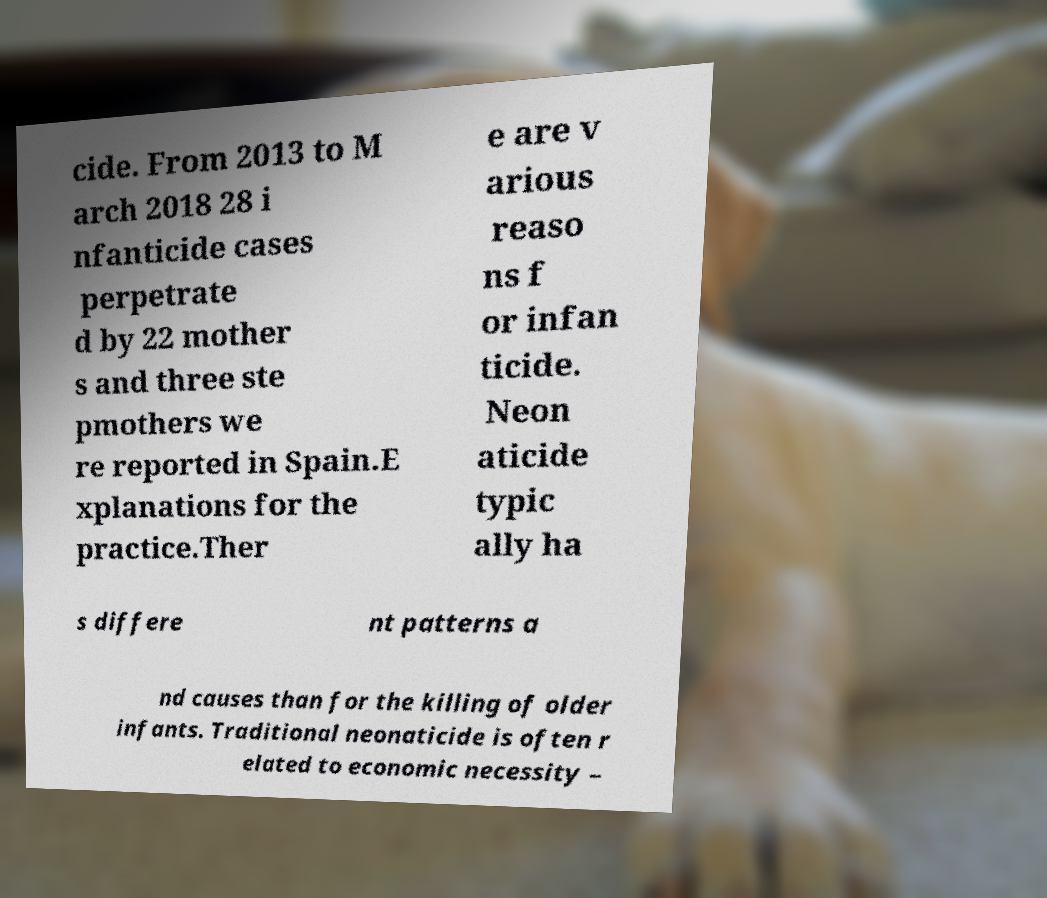Please identify and transcribe the text found in this image. cide. From 2013 to M arch 2018 28 i nfanticide cases perpetrate d by 22 mother s and three ste pmothers we re reported in Spain.E xplanations for the practice.Ther e are v arious reaso ns f or infan ticide. Neon aticide typic ally ha s differe nt patterns a nd causes than for the killing of older infants. Traditional neonaticide is often r elated to economic necessity – 